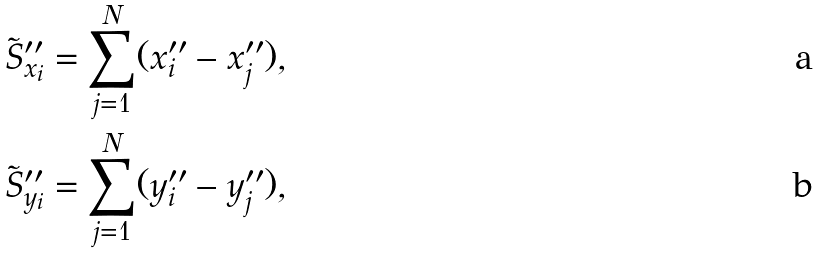<formula> <loc_0><loc_0><loc_500><loc_500>\tilde { S } _ { x _ { i } } ^ { \prime \prime } = \sum _ { j = 1 } ^ { N } ( x _ { i } ^ { \prime \prime } - x _ { j } ^ { \prime \prime } ) , \\ \tilde { S } _ { y _ { i } } ^ { \prime \prime } = \sum _ { j = 1 } ^ { N } ( y _ { i } ^ { \prime \prime } - y _ { j } ^ { \prime \prime } ) ,</formula> 